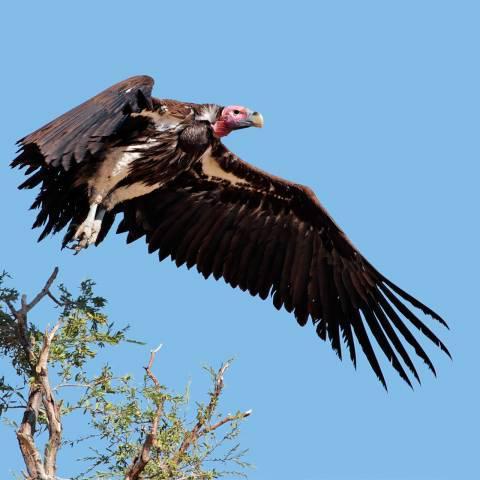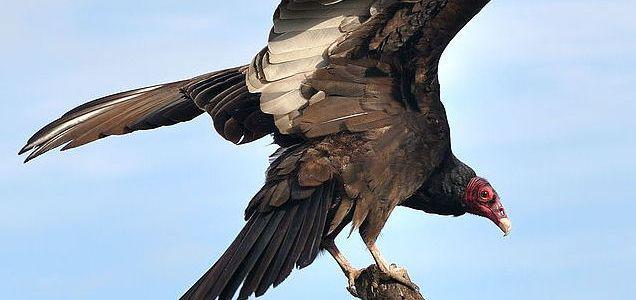The first image is the image on the left, the second image is the image on the right. Analyze the images presented: Is the assertion "A branch is visible only in the right image of a vulture." valid? Answer yes or no. No. 